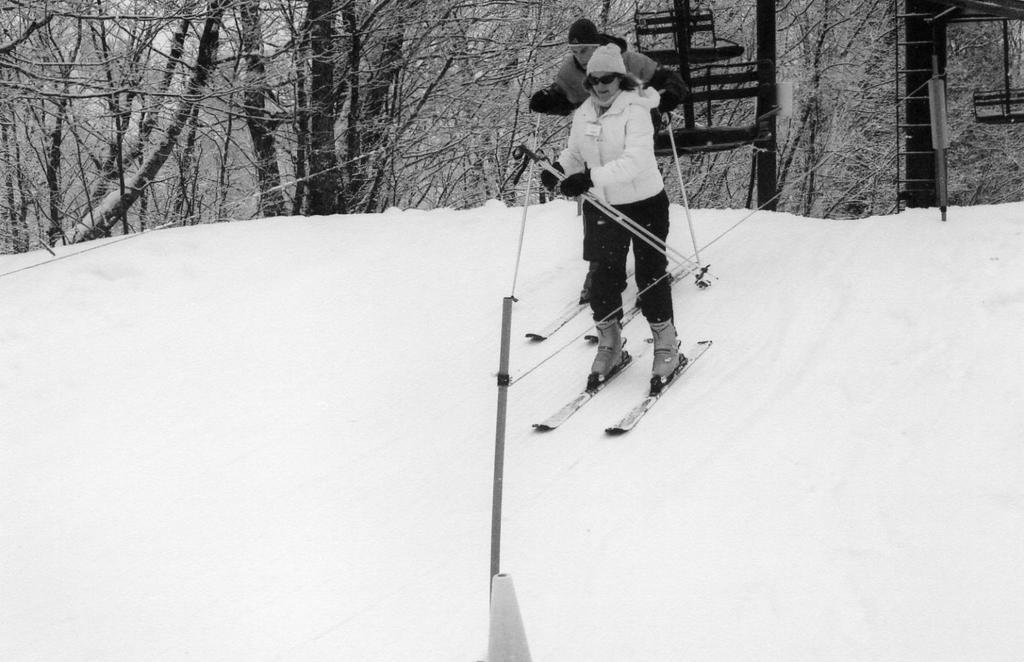What are the man and woman doing in the image? Both the man and woman are skating on snow in the image. What can be seen in the background of the image? There are trees in the background of the image. What type of produce can be seen in the image? There is no produce present in the image; it features a man and a woman skating on snow. What type of agreement can be seen between the man and woman in the image? There is no agreement visible between the man and woman in the image; they are simply skating on snow. 